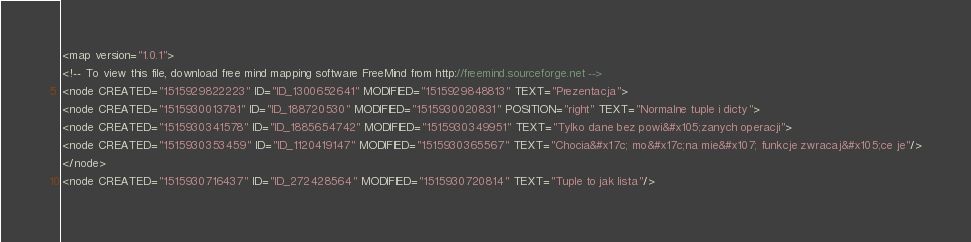<code> <loc_0><loc_0><loc_500><loc_500><_ObjectiveC_><map version="1.0.1">
<!-- To view this file, download free mind mapping software FreeMind from http://freemind.sourceforge.net -->
<node CREATED="1515929822223" ID="ID_1300652641" MODIFIED="1515929848813" TEXT="Prezentacja">
<node CREATED="1515930013781" ID="ID_188720530" MODIFIED="1515930020831" POSITION="right" TEXT="Normalne tuple i dicty">
<node CREATED="1515930341578" ID="ID_1885654742" MODIFIED="1515930349951" TEXT="Tylko dane bez powi&#x105;zanych operacji">
<node CREATED="1515930353459" ID="ID_1120419147" MODIFIED="1515930365567" TEXT="Chocia&#x17c; mo&#x17c;na mie&#x107; funkcje zwracaj&#x105;ce je"/>
</node>
<node CREATED="1515930716437" ID="ID_272428564" MODIFIED="1515930720814" TEXT="Tuple to jak lista"/></code> 